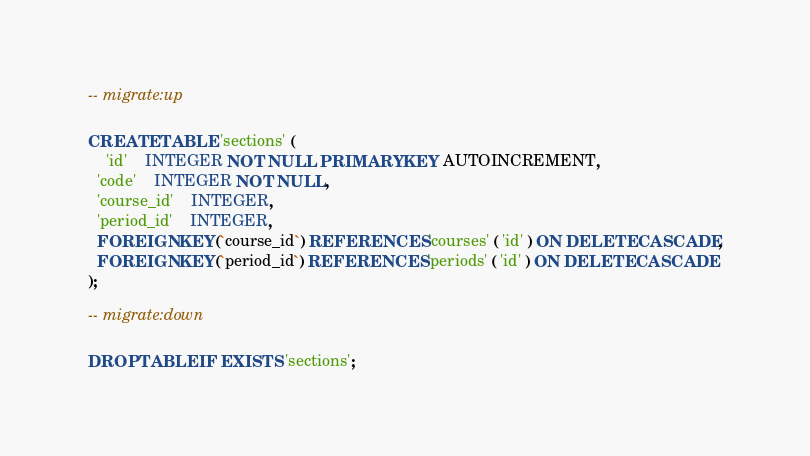Convert code to text. <code><loc_0><loc_0><loc_500><loc_500><_SQL_>-- migrate:up

CREATE TABLE 'sections' (
	'id'	INTEGER NOT NULL PRIMARY KEY AUTOINCREMENT,
  'code'	INTEGER NOT NULL,
  'course_id'	INTEGER,
  'period_id'	INTEGER,
  FOREIGN KEY(`course_id`) REFERENCES 'courses' ( 'id' ) ON DELETE CASCADE,
  FOREIGN KEY(`period_id`) REFERENCES 'periods' ( 'id' ) ON DELETE CASCADE
);

-- migrate:down

DROP TABLE IF EXISTS 'sections';</code> 